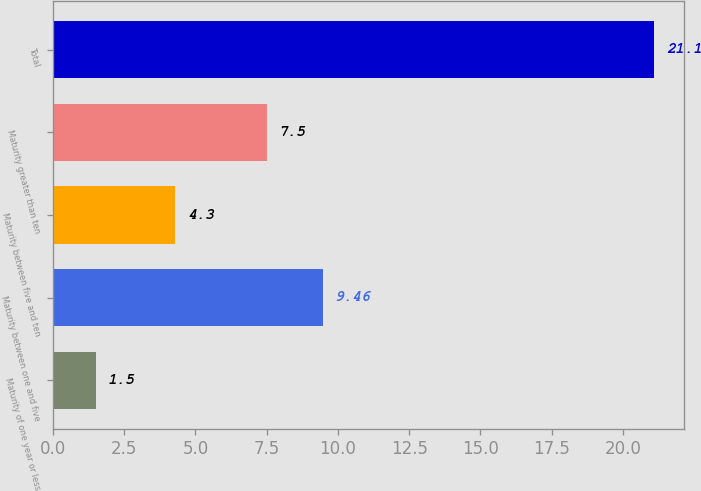Convert chart to OTSL. <chart><loc_0><loc_0><loc_500><loc_500><bar_chart><fcel>Maturity of one year or less<fcel>Maturity between one and five<fcel>Maturity between five and ten<fcel>Maturity greater than ten<fcel>Total<nl><fcel>1.5<fcel>9.46<fcel>4.3<fcel>7.5<fcel>21.1<nl></chart> 